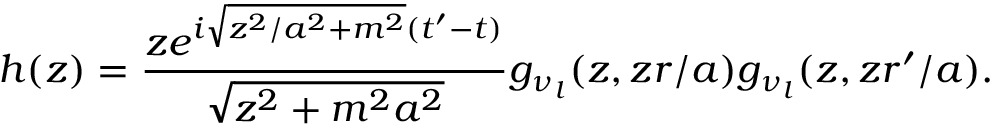<formula> <loc_0><loc_0><loc_500><loc_500>h ( z ) = \frac { z e ^ { i \sqrt { z ^ { 2 } / a ^ { 2 } + m ^ { 2 } } ( t ^ { \prime } - t ) } } { \sqrt { z ^ { 2 } + m ^ { 2 } a ^ { 2 } } } g _ { \nu _ { l } } ( z , z r / a ) g _ { \nu _ { l } } ( z , z r ^ { \prime } / a ) .</formula> 